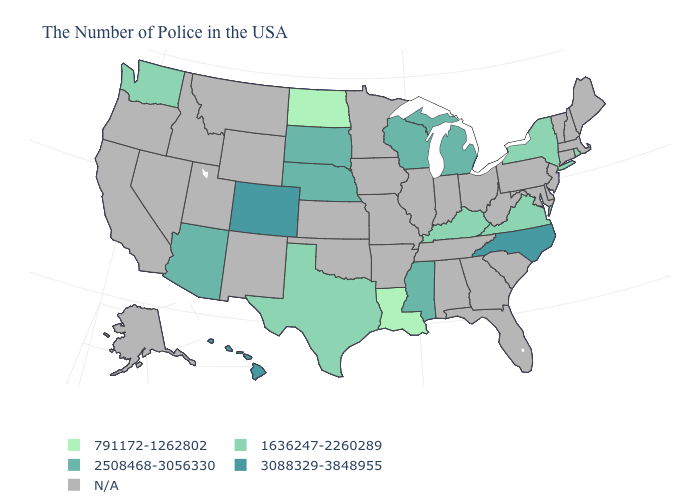Which states have the highest value in the USA?
Short answer required. North Carolina, Colorado, Hawaii. Among the states that border Oregon , which have the lowest value?
Give a very brief answer. Washington. How many symbols are there in the legend?
Give a very brief answer. 5. What is the value of Mississippi?
Be succinct. 2508468-3056330. What is the value of Tennessee?
Concise answer only. N/A. What is the value of Alaska?
Short answer required. N/A. Which states have the lowest value in the USA?
Be succinct. Louisiana, North Dakota. Name the states that have a value in the range N/A?
Be succinct. Maine, Massachusetts, New Hampshire, Vermont, Connecticut, New Jersey, Delaware, Maryland, Pennsylvania, South Carolina, West Virginia, Ohio, Florida, Georgia, Indiana, Alabama, Tennessee, Illinois, Missouri, Arkansas, Minnesota, Iowa, Kansas, Oklahoma, Wyoming, New Mexico, Utah, Montana, Idaho, Nevada, California, Oregon, Alaska. Name the states that have a value in the range 1636247-2260289?
Short answer required. Rhode Island, New York, Virginia, Kentucky, Texas, Washington. What is the value of Oregon?
Concise answer only. N/A. Does the first symbol in the legend represent the smallest category?
Concise answer only. Yes. Does North Dakota have the lowest value in the MidWest?
Quick response, please. Yes. 